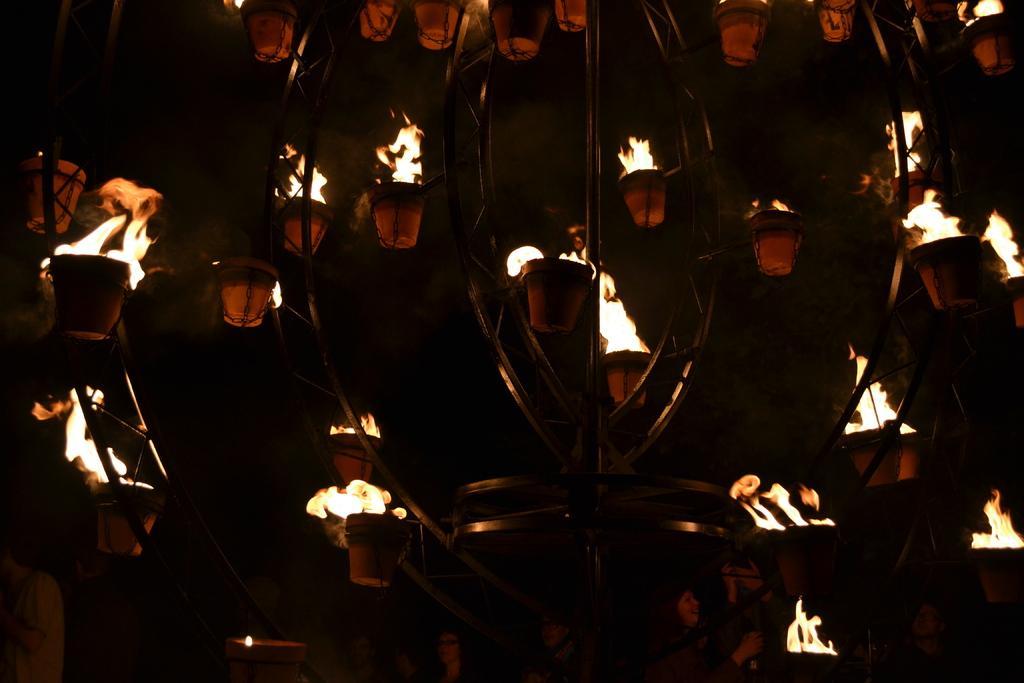Could you give a brief overview of what you see in this image? In this image I can see a metal stand which is black in color. To the stand I can see few pots and fire in the pots. In the background I can see the dark sky. 